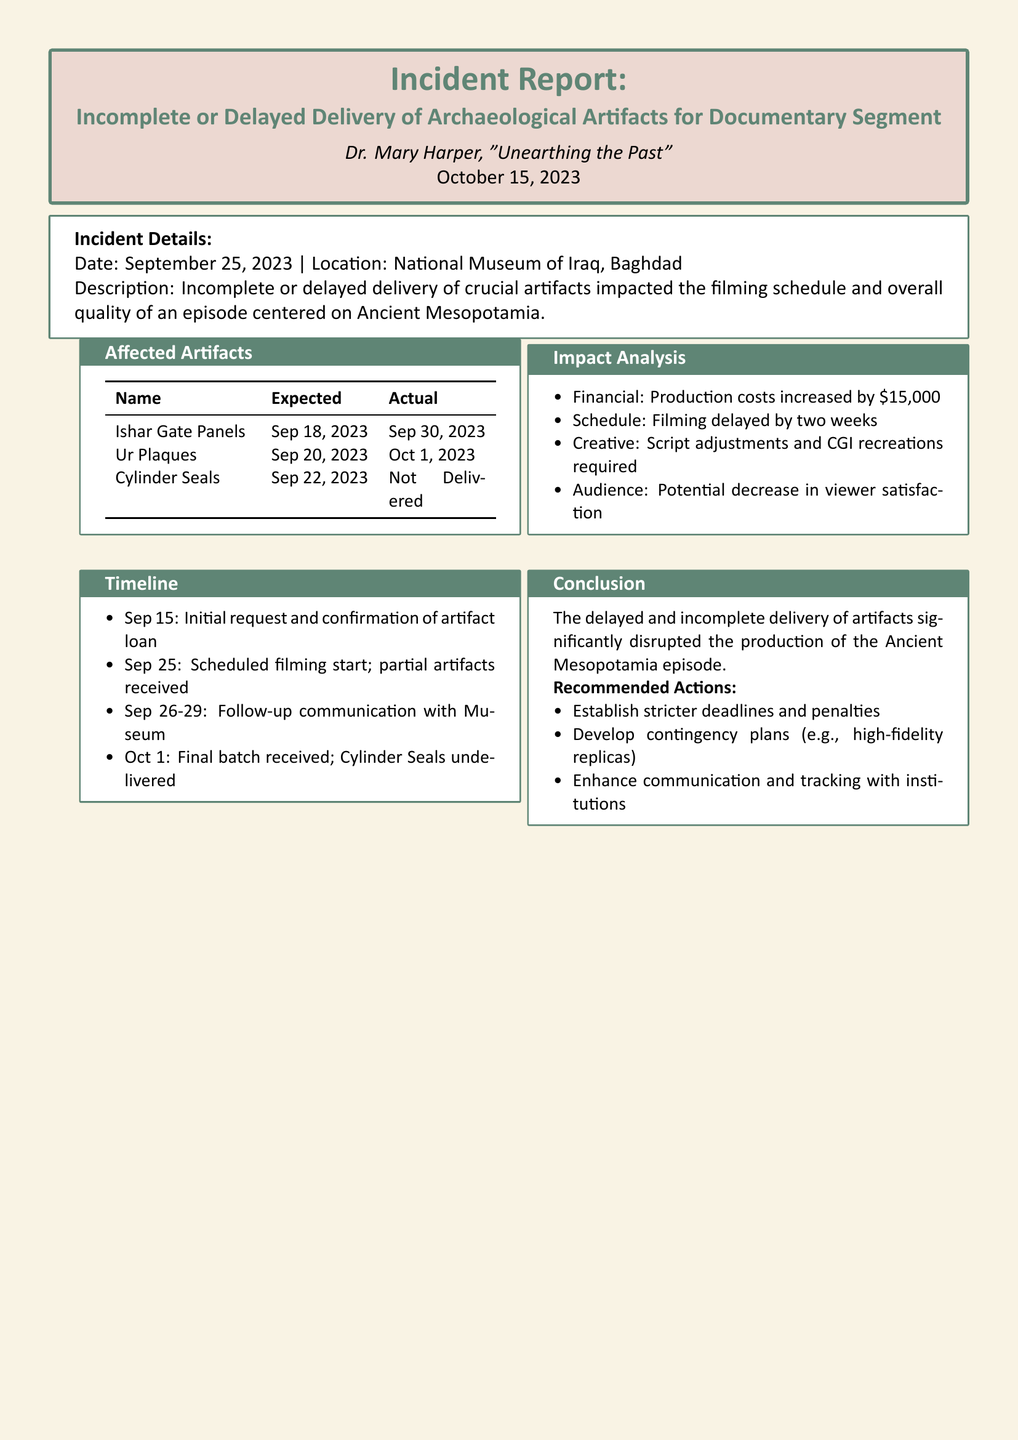what is the date of the incident? The date of the incident is mentioned as September 25, 2023.
Answer: September 25, 2023 who is the author of the incident report? The report states that it is authored by Dr. Mary Harper.
Answer: Dr. Mary Harper how many artifact names were affected? The document lists three affected artifacts.
Answer: three what was the expected delivery date for the Ishar Gate Panels? The expected delivery date for the Ishar Gate Panels is September 18, 2023.
Answer: September 18, 2023 how much did the production costs increase due to the incident? The increase in production costs due to the incident is specified as $15,000.
Answer: $15,000 what is the consequence of the delay in terms of filming schedule? The filming schedule was delayed by two weeks as stated in the impact analysis section.
Answer: two weeks what artifact was not delivered at all? The document states that the Cylinder Seals were not delivered.
Answer: Cylinder Seals what recommended action involves the delivery process? One of the recommended actions is to establish stricter deadlines and penalties.
Answer: stricter deadlines and penalties what was the filming start date according to the timeline? The scheduled filming start date was September 25, 2023.
Answer: September 25, 2023 